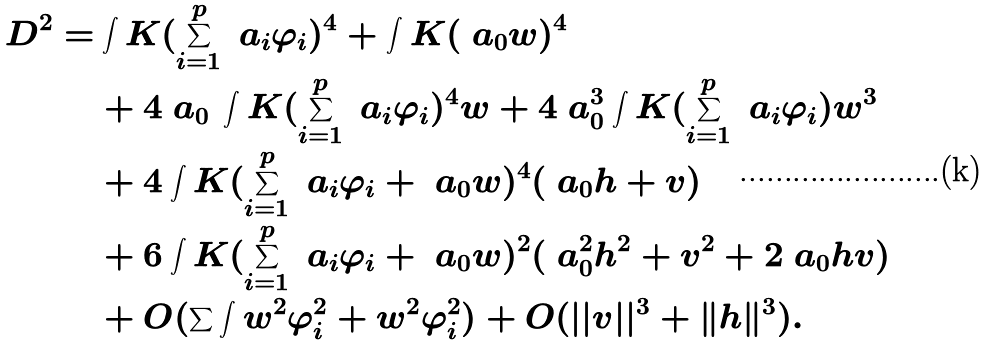Convert formula to latex. <formula><loc_0><loc_0><loc_500><loc_500>D ^ { 2 } = & \int K ( \sum _ { i = 1 } ^ { p } \ a _ { i } \varphi _ { i } ) ^ { 4 } + \int K ( \ a _ { 0 } w ) ^ { 4 } \\ & + 4 \ a _ { 0 } \, \int K ( \sum _ { i = 1 } ^ { p } \ a _ { i } \varphi _ { i } ) ^ { 4 } w + 4 \ a _ { 0 } ^ { 3 } \int K ( \sum _ { i = 1 } ^ { p } \ a _ { i } \varphi _ { i } ) w ^ { 3 } \\ & + 4 \int K ( \sum _ { i = 1 } ^ { p } \ a _ { i } \varphi _ { i } + \ a _ { 0 } w ) ^ { 4 } ( \ a _ { 0 } h + v ) \\ & + 6 \int K ( \sum _ { i = 1 } ^ { p } \ a _ { i } \varphi _ { i } + \ a _ { 0 } w ) ^ { 2 } ( \ a _ { 0 } ^ { 2 } h ^ { 2 } + v ^ { 2 } + 2 \ a _ { 0 } h v ) \\ & + O ( \sum \int w ^ { 2 } \varphi _ { i } ^ { 2 } + w ^ { 2 } \varphi _ { i } ^ { 2 } ) + O ( | | v | | ^ { 3 } + \| h \| ^ { 3 } ) .</formula> 